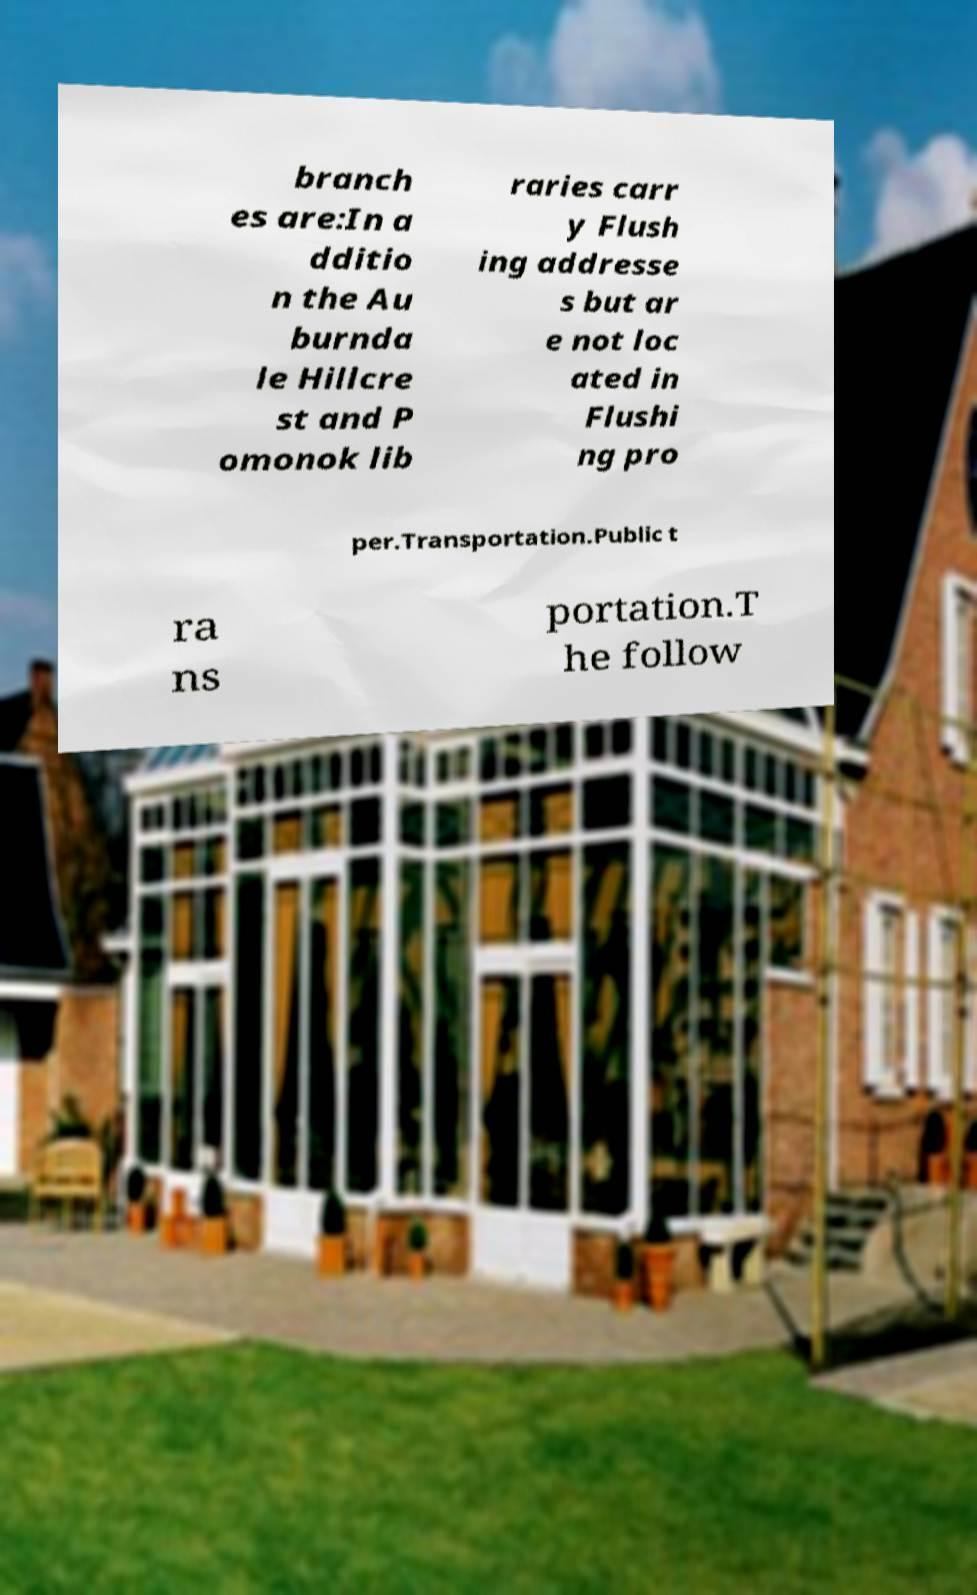Could you assist in decoding the text presented in this image and type it out clearly? branch es are:In a dditio n the Au burnda le Hillcre st and P omonok lib raries carr y Flush ing addresse s but ar e not loc ated in Flushi ng pro per.Transportation.Public t ra ns portation.T he follow 